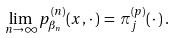<formula> <loc_0><loc_0><loc_500><loc_500>\lim _ { n \to \infty } p ^ { ( n ) } _ { \beta _ { n } } ( x , \, \cdot \, ) \, = \, \pi ^ { ( p ) } _ { j } ( \, \cdot \, ) \, .</formula> 